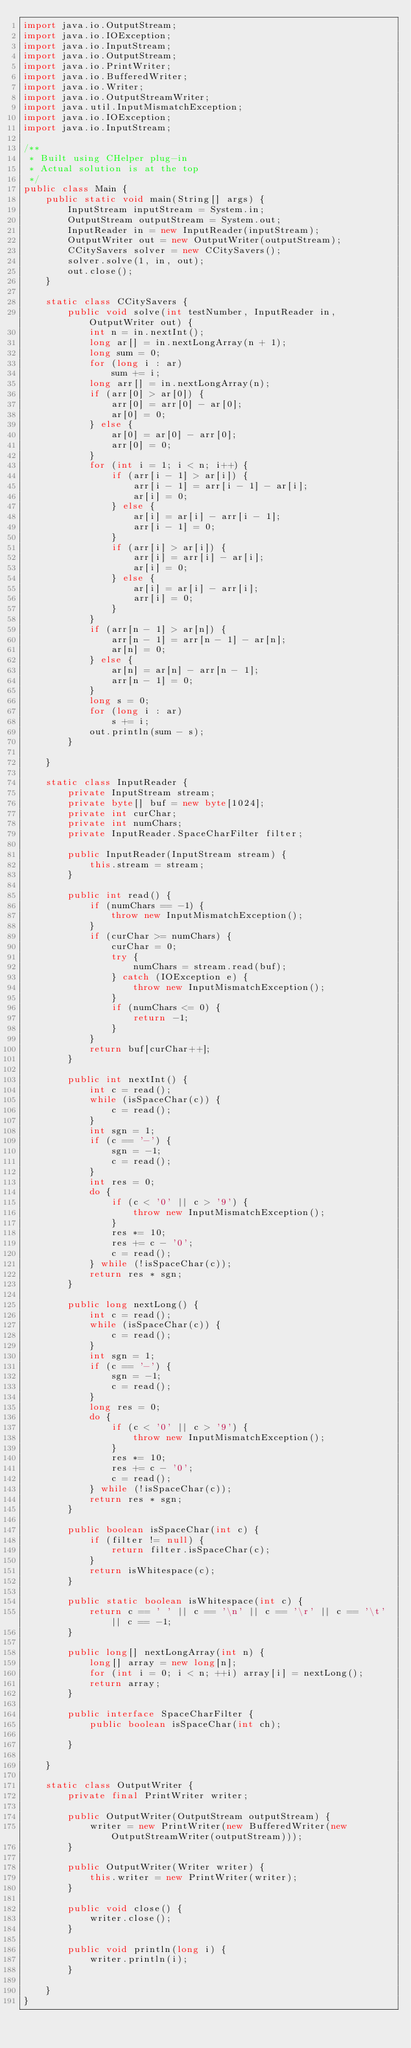Convert code to text. <code><loc_0><loc_0><loc_500><loc_500><_Java_>import java.io.OutputStream;
import java.io.IOException;
import java.io.InputStream;
import java.io.OutputStream;
import java.io.PrintWriter;
import java.io.BufferedWriter;
import java.io.Writer;
import java.io.OutputStreamWriter;
import java.util.InputMismatchException;
import java.io.IOException;
import java.io.InputStream;

/**
 * Built using CHelper plug-in
 * Actual solution is at the top
 */
public class Main {
    public static void main(String[] args) {
        InputStream inputStream = System.in;
        OutputStream outputStream = System.out;
        InputReader in = new InputReader(inputStream);
        OutputWriter out = new OutputWriter(outputStream);
        CCitySavers solver = new CCitySavers();
        solver.solve(1, in, out);
        out.close();
    }

    static class CCitySavers {
        public void solve(int testNumber, InputReader in, OutputWriter out) {
            int n = in.nextInt();
            long ar[] = in.nextLongArray(n + 1);
            long sum = 0;
            for (long i : ar)
                sum += i;
            long arr[] = in.nextLongArray(n);
            if (arr[0] > ar[0]) {
                arr[0] = arr[0] - ar[0];
                ar[0] = 0;
            } else {
                ar[0] = ar[0] - arr[0];
                arr[0] = 0;
            }
            for (int i = 1; i < n; i++) {
                if (arr[i - 1] > ar[i]) {
                    arr[i - 1] = arr[i - 1] - ar[i];
                    ar[i] = 0;
                } else {
                    ar[i] = ar[i] - arr[i - 1];
                    arr[i - 1] = 0;
                }
                if (arr[i] > ar[i]) {
                    arr[i] = arr[i] - ar[i];
                    ar[i] = 0;
                } else {
                    ar[i] = ar[i] - arr[i];
                    arr[i] = 0;
                }
            }
            if (arr[n - 1] > ar[n]) {
                arr[n - 1] = arr[n - 1] - ar[n];
                ar[n] = 0;
            } else {
                ar[n] = ar[n] - arr[n - 1];
                arr[n - 1] = 0;
            }
            long s = 0;
            for (long i : ar)
                s += i;
            out.println(sum - s);
        }

    }

    static class InputReader {
        private InputStream stream;
        private byte[] buf = new byte[1024];
        private int curChar;
        private int numChars;
        private InputReader.SpaceCharFilter filter;

        public InputReader(InputStream stream) {
            this.stream = stream;
        }

        public int read() {
            if (numChars == -1) {
                throw new InputMismatchException();
            }
            if (curChar >= numChars) {
                curChar = 0;
                try {
                    numChars = stream.read(buf);
                } catch (IOException e) {
                    throw new InputMismatchException();
                }
                if (numChars <= 0) {
                    return -1;
                }
            }
            return buf[curChar++];
        }

        public int nextInt() {
            int c = read();
            while (isSpaceChar(c)) {
                c = read();
            }
            int sgn = 1;
            if (c == '-') {
                sgn = -1;
                c = read();
            }
            int res = 0;
            do {
                if (c < '0' || c > '9') {
                    throw new InputMismatchException();
                }
                res *= 10;
                res += c - '0';
                c = read();
            } while (!isSpaceChar(c));
            return res * sgn;
        }

        public long nextLong() {
            int c = read();
            while (isSpaceChar(c)) {
                c = read();
            }
            int sgn = 1;
            if (c == '-') {
                sgn = -1;
                c = read();
            }
            long res = 0;
            do {
                if (c < '0' || c > '9') {
                    throw new InputMismatchException();
                }
                res *= 10;
                res += c - '0';
                c = read();
            } while (!isSpaceChar(c));
            return res * sgn;
        }

        public boolean isSpaceChar(int c) {
            if (filter != null) {
                return filter.isSpaceChar(c);
            }
            return isWhitespace(c);
        }

        public static boolean isWhitespace(int c) {
            return c == ' ' || c == '\n' || c == '\r' || c == '\t' || c == -1;
        }

        public long[] nextLongArray(int n) {
            long[] array = new long[n];
            for (int i = 0; i < n; ++i) array[i] = nextLong();
            return array;
        }

        public interface SpaceCharFilter {
            public boolean isSpaceChar(int ch);

        }

    }

    static class OutputWriter {
        private final PrintWriter writer;

        public OutputWriter(OutputStream outputStream) {
            writer = new PrintWriter(new BufferedWriter(new OutputStreamWriter(outputStream)));
        }

        public OutputWriter(Writer writer) {
            this.writer = new PrintWriter(writer);
        }

        public void close() {
            writer.close();
        }

        public void println(long i) {
            writer.println(i);
        }

    }
}

</code> 